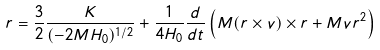<formula> <loc_0><loc_0><loc_500><loc_500>r = \frac { 3 } { 2 } \frac { K } { ( - 2 M H _ { 0 } ) ^ { 1 / 2 } } + \frac { 1 } { 4 H _ { 0 } } \frac { d } { d t } \left ( M ( r \times v ) \times r + M v r ^ { 2 } \right )</formula> 